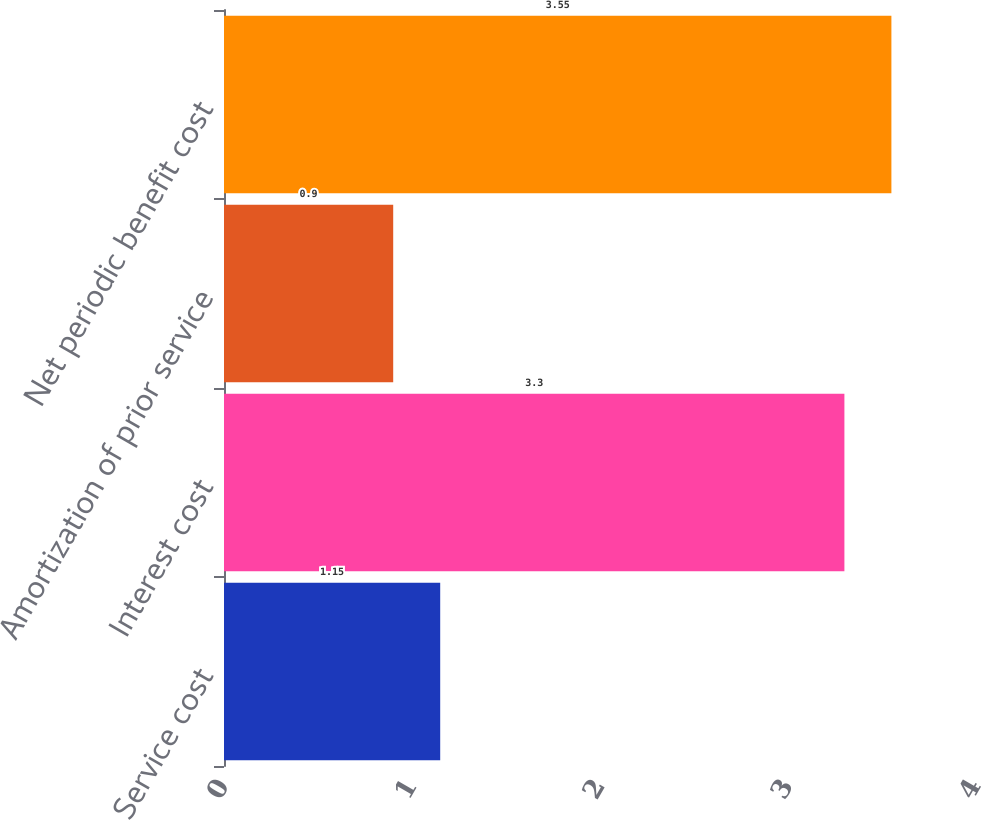Convert chart. <chart><loc_0><loc_0><loc_500><loc_500><bar_chart><fcel>Service cost<fcel>Interest cost<fcel>Amortization of prior service<fcel>Net periodic benefit cost<nl><fcel>1.15<fcel>3.3<fcel>0.9<fcel>3.55<nl></chart> 